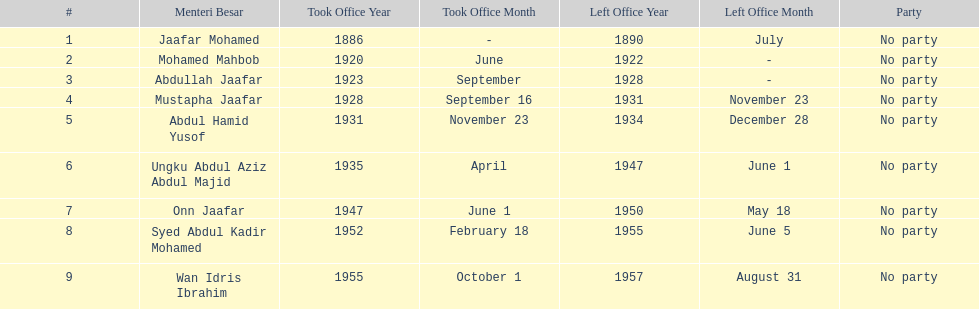What is the number of menteri besar that served 4 or more years? 3. 